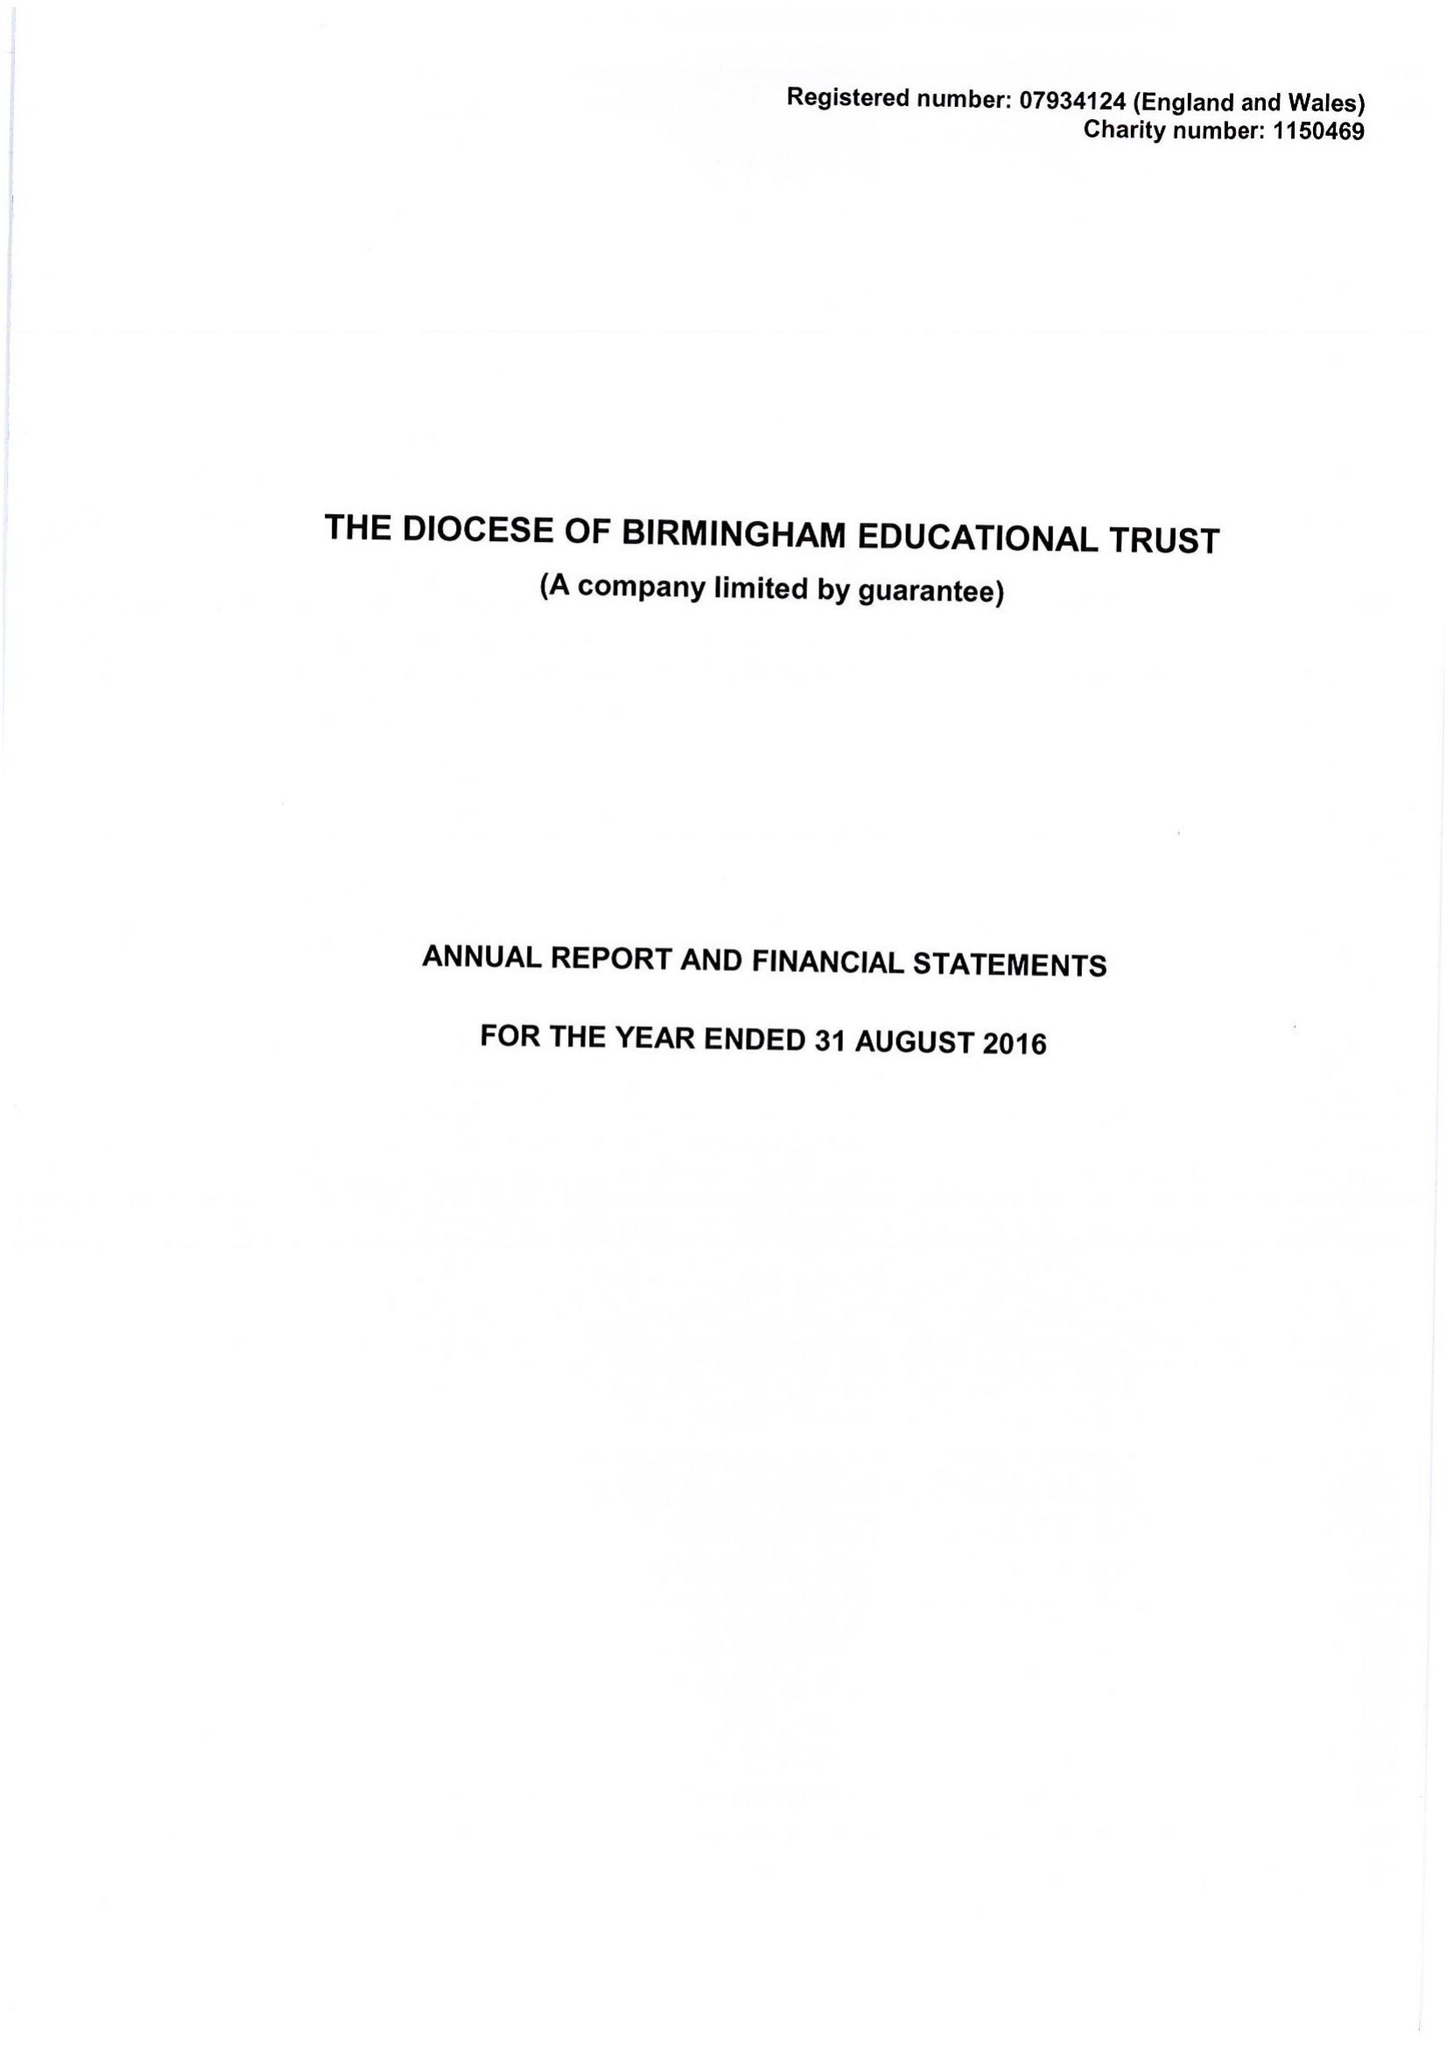What is the value for the spending_annually_in_british_pounds?
Answer the question using a single word or phrase. 233422.00 